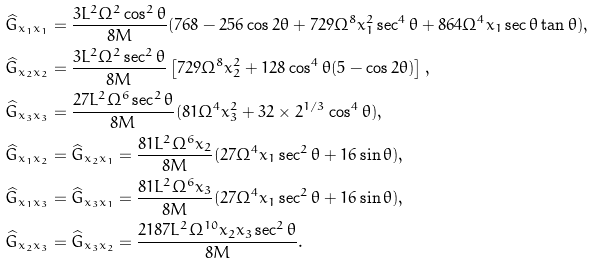<formula> <loc_0><loc_0><loc_500><loc_500>& \widehat { G } _ { x _ { 1 } x _ { 1 } } = \frac { 3 L ^ { 2 } \Omega ^ { 2 } \cos ^ { 2 } \theta } { 8 M } ( 7 6 8 - 2 5 6 \cos 2 \theta + 7 2 9 \Omega ^ { 8 } x _ { 1 } ^ { 2 } \sec ^ { 4 } \theta + 8 6 4 \Omega ^ { 4 } x _ { 1 } \sec \theta \tan \theta ) , \\ & \widehat { G } _ { x _ { 2 } x _ { 2 } } = \frac { 3 L ^ { 2 } \Omega ^ { 2 } \sec ^ { 2 } \theta } { 8 M } \left [ 7 2 9 \Omega ^ { 8 } x _ { 2 } ^ { 2 } + 1 2 8 \cos ^ { 4 } \theta ( 5 - \cos 2 \theta ) \right ] , \\ & \widehat { G } _ { x _ { 3 } x _ { 3 } } = \frac { 2 7 L ^ { 2 } \Omega ^ { 6 } \sec ^ { 2 } \theta } { 8 M } ( 8 1 \Omega ^ { 4 } x _ { 3 } ^ { 2 } + 3 2 \times 2 ^ { 1 / 3 } \cos ^ { 4 } \theta ) , \\ & \widehat { G } _ { x _ { 1 } x _ { 2 } } = \widehat { G } _ { x _ { 2 } x _ { 1 } } = \frac { 8 1 L ^ { 2 } \Omega ^ { 6 } x _ { 2 } } { 8 M } ( 2 7 \Omega ^ { 4 } x _ { 1 } \sec ^ { 2 } \theta + 1 6 \sin \theta ) , \\ & \widehat { G } _ { x _ { 1 } x _ { 3 } } = \widehat { G } _ { x _ { 3 } x _ { 1 } } = \frac { 8 1 L ^ { 2 } \Omega ^ { 6 } x _ { 3 } } { 8 M } ( 2 7 \Omega ^ { 4 } x _ { 1 } \sec ^ { 2 } \theta + 1 6 \sin \theta ) , \\ & \widehat { G } _ { x _ { 2 } x _ { 3 } } = \widehat { G } _ { x _ { 3 } x _ { 2 } } = \frac { 2 1 8 7 L ^ { 2 } \Omega ^ { 1 0 } x _ { 2 } x _ { 3 } \sec ^ { 2 } \theta } { 8 M } .</formula> 